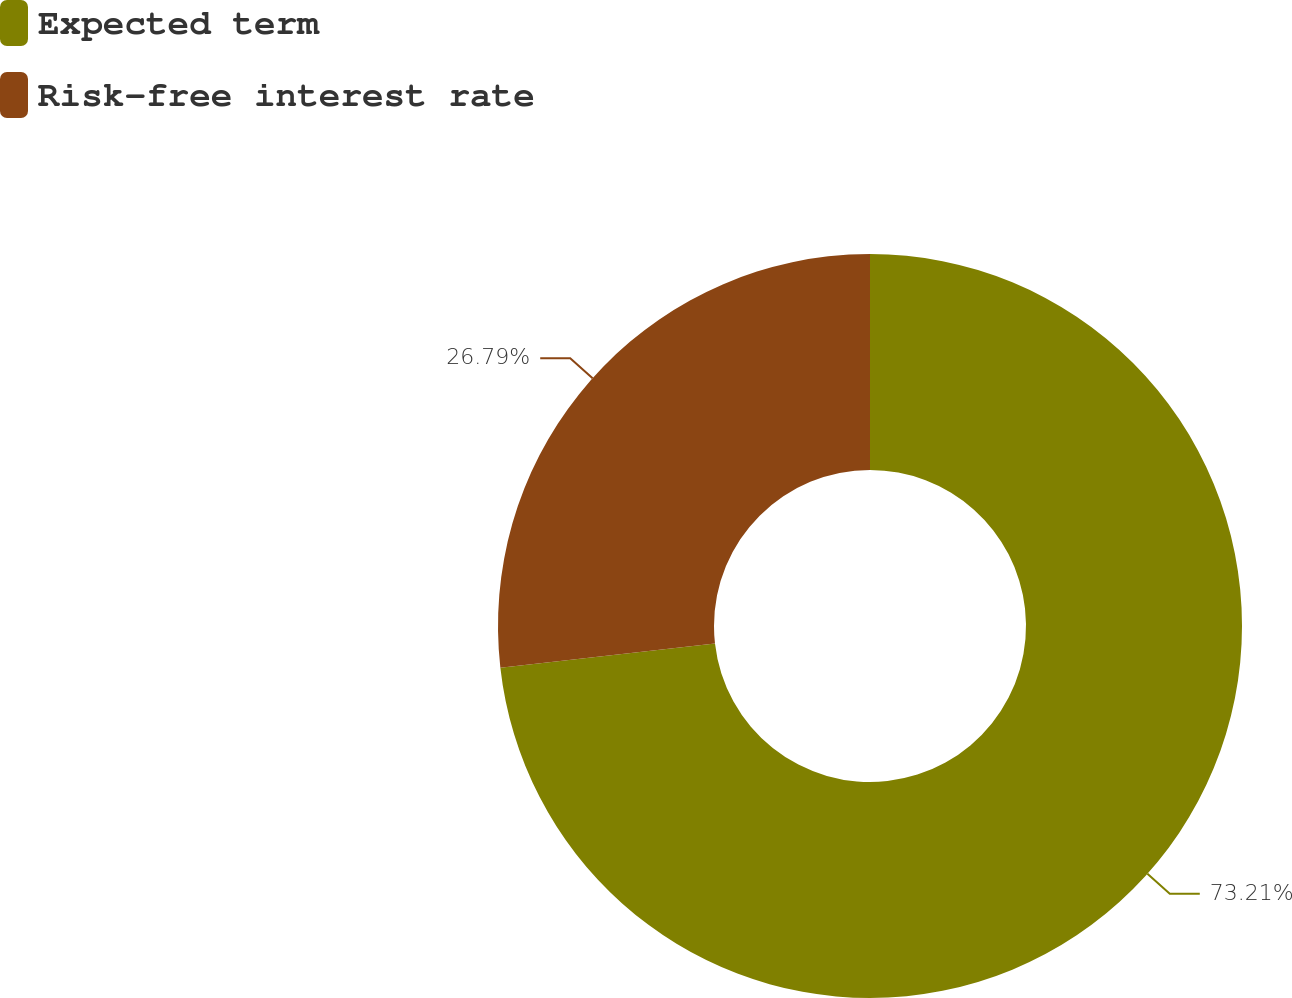<chart> <loc_0><loc_0><loc_500><loc_500><pie_chart><fcel>Expected term<fcel>Risk-free interest rate<nl><fcel>73.21%<fcel>26.79%<nl></chart> 